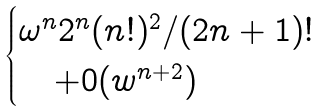<formula> <loc_0><loc_0><loc_500><loc_500>\begin{cases} \omega ^ { n } 2 ^ { n } ( n ! ) ^ { 2 } / ( 2 n + 1 ) ! \\ \quad + 0 ( w ^ { n + 2 } ) \end{cases}</formula> 